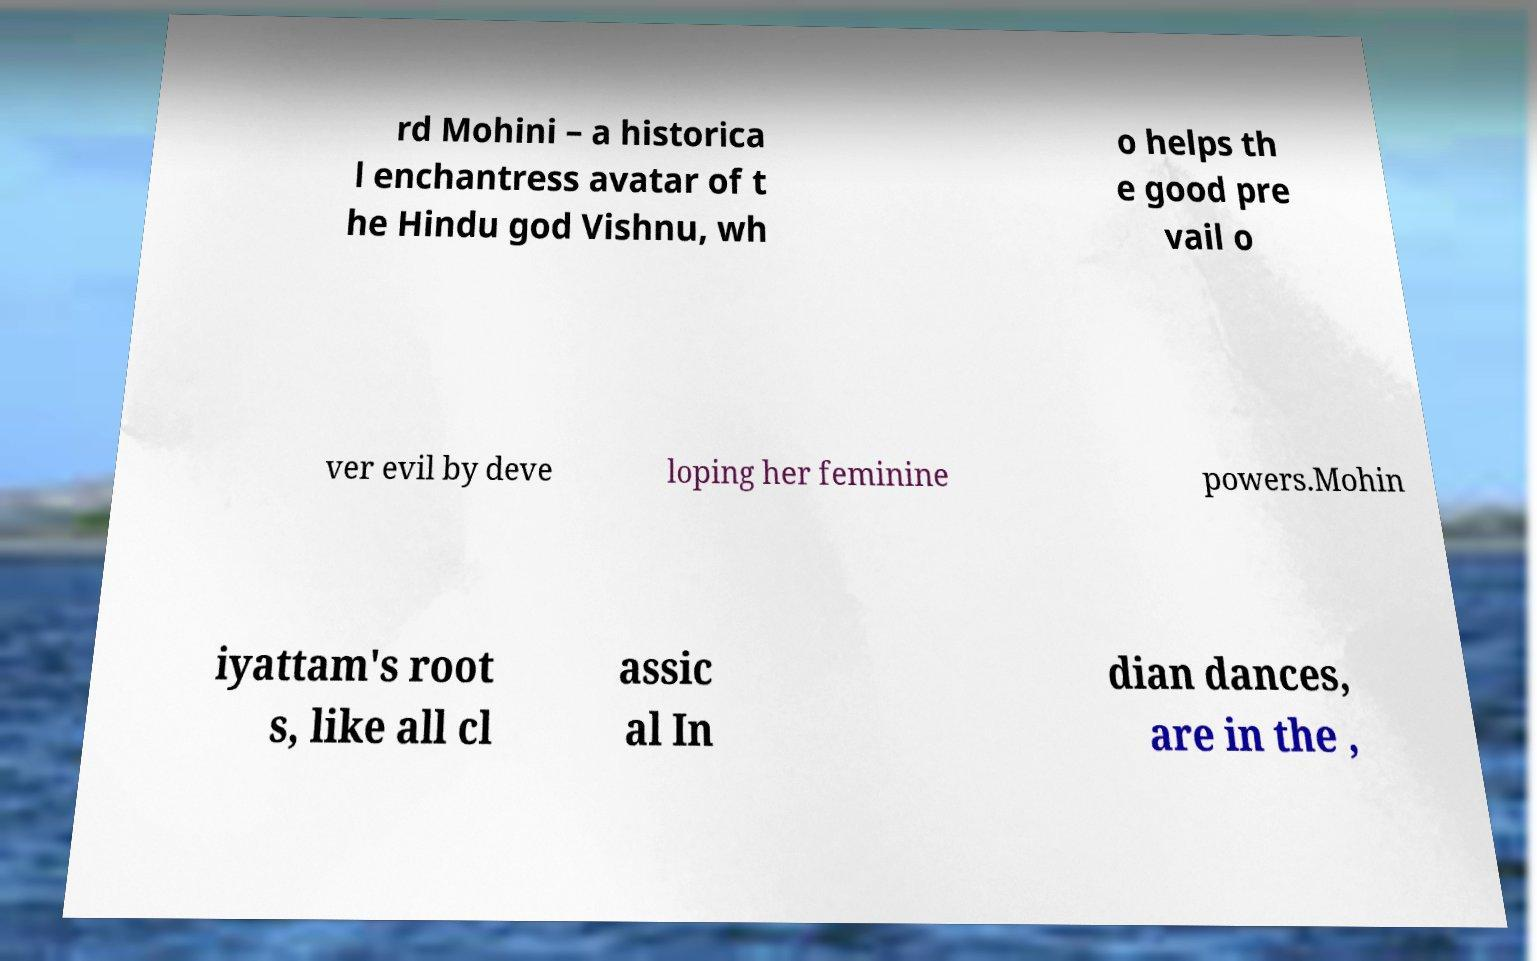Could you extract and type out the text from this image? rd Mohini – a historica l enchantress avatar of t he Hindu god Vishnu, wh o helps th e good pre vail o ver evil by deve loping her feminine powers.Mohin iyattam's root s, like all cl assic al In dian dances, are in the , 